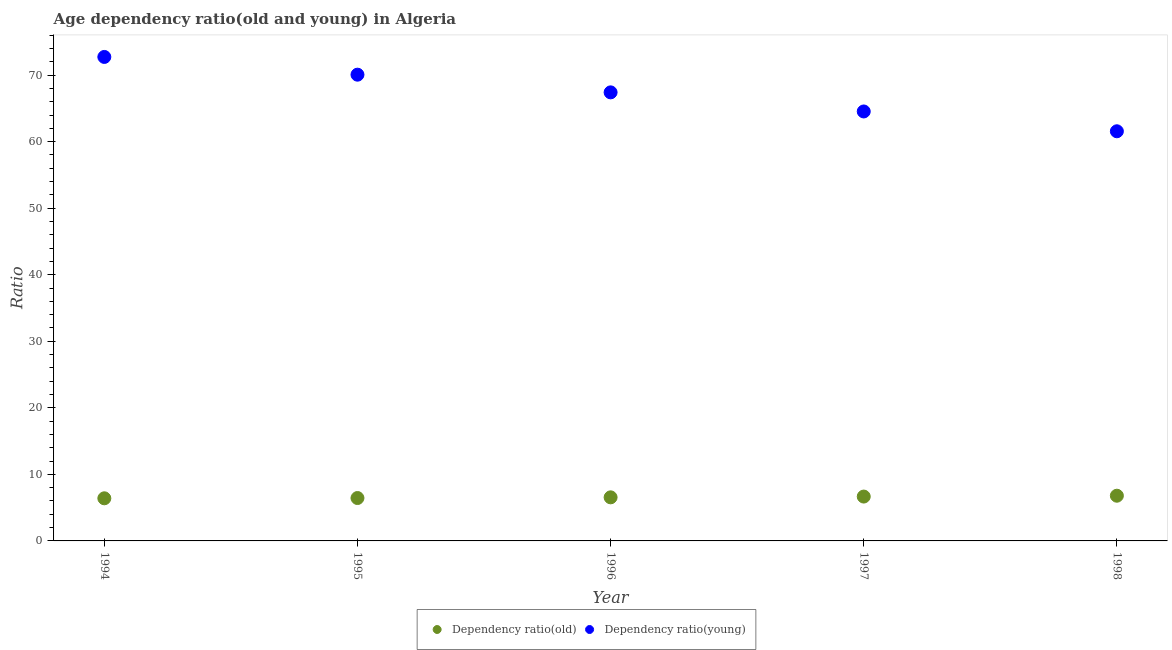How many different coloured dotlines are there?
Ensure brevity in your answer.  2. Is the number of dotlines equal to the number of legend labels?
Your answer should be very brief. Yes. What is the age dependency ratio(old) in 1994?
Make the answer very short. 6.41. Across all years, what is the maximum age dependency ratio(young)?
Offer a very short reply. 72.74. Across all years, what is the minimum age dependency ratio(young)?
Keep it short and to the point. 61.57. In which year was the age dependency ratio(young) maximum?
Your answer should be very brief. 1994. In which year was the age dependency ratio(young) minimum?
Offer a terse response. 1998. What is the total age dependency ratio(old) in the graph?
Keep it short and to the point. 32.86. What is the difference between the age dependency ratio(old) in 1996 and that in 1998?
Your response must be concise. -0.24. What is the difference between the age dependency ratio(young) in 1994 and the age dependency ratio(old) in 1998?
Ensure brevity in your answer.  65.94. What is the average age dependency ratio(young) per year?
Make the answer very short. 67.27. In the year 1998, what is the difference between the age dependency ratio(old) and age dependency ratio(young)?
Your answer should be compact. -54.77. In how many years, is the age dependency ratio(old) greater than 2?
Ensure brevity in your answer.  5. What is the ratio of the age dependency ratio(old) in 1994 to that in 1996?
Offer a very short reply. 0.98. Is the difference between the age dependency ratio(old) in 1994 and 1996 greater than the difference between the age dependency ratio(young) in 1994 and 1996?
Your response must be concise. No. What is the difference between the highest and the second highest age dependency ratio(young)?
Offer a terse response. 2.67. What is the difference between the highest and the lowest age dependency ratio(old)?
Offer a terse response. 0.39. Does the age dependency ratio(old) monotonically increase over the years?
Your answer should be very brief. Yes. What is the difference between two consecutive major ticks on the Y-axis?
Keep it short and to the point. 10. Are the values on the major ticks of Y-axis written in scientific E-notation?
Offer a very short reply. No. Where does the legend appear in the graph?
Give a very brief answer. Bottom center. How many legend labels are there?
Offer a terse response. 2. How are the legend labels stacked?
Offer a very short reply. Horizontal. What is the title of the graph?
Your answer should be compact. Age dependency ratio(old and young) in Algeria. Does "Underweight" appear as one of the legend labels in the graph?
Your answer should be very brief. No. What is the label or title of the X-axis?
Provide a short and direct response. Year. What is the label or title of the Y-axis?
Ensure brevity in your answer.  Ratio. What is the Ratio in Dependency ratio(old) in 1994?
Make the answer very short. 6.41. What is the Ratio in Dependency ratio(young) in 1994?
Offer a terse response. 72.74. What is the Ratio in Dependency ratio(old) in 1995?
Provide a short and direct response. 6.45. What is the Ratio of Dependency ratio(young) in 1995?
Give a very brief answer. 70.07. What is the Ratio in Dependency ratio(old) in 1996?
Your answer should be very brief. 6.55. What is the Ratio in Dependency ratio(young) in 1996?
Ensure brevity in your answer.  67.41. What is the Ratio of Dependency ratio(old) in 1997?
Offer a very short reply. 6.67. What is the Ratio of Dependency ratio(young) in 1997?
Your answer should be compact. 64.54. What is the Ratio of Dependency ratio(old) in 1998?
Your answer should be very brief. 6.79. What is the Ratio in Dependency ratio(young) in 1998?
Give a very brief answer. 61.57. Across all years, what is the maximum Ratio in Dependency ratio(old)?
Keep it short and to the point. 6.79. Across all years, what is the maximum Ratio of Dependency ratio(young)?
Keep it short and to the point. 72.74. Across all years, what is the minimum Ratio in Dependency ratio(old)?
Provide a succinct answer. 6.41. Across all years, what is the minimum Ratio in Dependency ratio(young)?
Provide a short and direct response. 61.57. What is the total Ratio of Dependency ratio(old) in the graph?
Make the answer very short. 32.86. What is the total Ratio of Dependency ratio(young) in the graph?
Ensure brevity in your answer.  336.33. What is the difference between the Ratio in Dependency ratio(old) in 1994 and that in 1995?
Provide a succinct answer. -0.04. What is the difference between the Ratio in Dependency ratio(young) in 1994 and that in 1995?
Your answer should be very brief. 2.67. What is the difference between the Ratio in Dependency ratio(old) in 1994 and that in 1996?
Provide a succinct answer. -0.14. What is the difference between the Ratio of Dependency ratio(young) in 1994 and that in 1996?
Provide a succinct answer. 5.32. What is the difference between the Ratio in Dependency ratio(old) in 1994 and that in 1997?
Give a very brief answer. -0.26. What is the difference between the Ratio of Dependency ratio(young) in 1994 and that in 1997?
Provide a succinct answer. 8.19. What is the difference between the Ratio of Dependency ratio(old) in 1994 and that in 1998?
Provide a succinct answer. -0.39. What is the difference between the Ratio in Dependency ratio(young) in 1994 and that in 1998?
Your answer should be very brief. 11.17. What is the difference between the Ratio in Dependency ratio(old) in 1995 and that in 1996?
Provide a short and direct response. -0.1. What is the difference between the Ratio of Dependency ratio(young) in 1995 and that in 1996?
Ensure brevity in your answer.  2.66. What is the difference between the Ratio of Dependency ratio(old) in 1995 and that in 1997?
Your answer should be compact. -0.22. What is the difference between the Ratio of Dependency ratio(young) in 1995 and that in 1997?
Offer a very short reply. 5.53. What is the difference between the Ratio of Dependency ratio(old) in 1995 and that in 1998?
Your answer should be compact. -0.35. What is the difference between the Ratio in Dependency ratio(young) in 1995 and that in 1998?
Provide a succinct answer. 8.51. What is the difference between the Ratio in Dependency ratio(old) in 1996 and that in 1997?
Give a very brief answer. -0.12. What is the difference between the Ratio in Dependency ratio(young) in 1996 and that in 1997?
Your response must be concise. 2.87. What is the difference between the Ratio of Dependency ratio(old) in 1996 and that in 1998?
Your response must be concise. -0.24. What is the difference between the Ratio in Dependency ratio(young) in 1996 and that in 1998?
Provide a succinct answer. 5.85. What is the difference between the Ratio of Dependency ratio(old) in 1997 and that in 1998?
Make the answer very short. -0.13. What is the difference between the Ratio in Dependency ratio(young) in 1997 and that in 1998?
Provide a short and direct response. 2.98. What is the difference between the Ratio of Dependency ratio(old) in 1994 and the Ratio of Dependency ratio(young) in 1995?
Ensure brevity in your answer.  -63.67. What is the difference between the Ratio of Dependency ratio(old) in 1994 and the Ratio of Dependency ratio(young) in 1996?
Make the answer very short. -61.01. What is the difference between the Ratio of Dependency ratio(old) in 1994 and the Ratio of Dependency ratio(young) in 1997?
Provide a succinct answer. -58.14. What is the difference between the Ratio of Dependency ratio(old) in 1994 and the Ratio of Dependency ratio(young) in 1998?
Your answer should be compact. -55.16. What is the difference between the Ratio of Dependency ratio(old) in 1995 and the Ratio of Dependency ratio(young) in 1996?
Make the answer very short. -60.97. What is the difference between the Ratio in Dependency ratio(old) in 1995 and the Ratio in Dependency ratio(young) in 1997?
Your answer should be very brief. -58.1. What is the difference between the Ratio of Dependency ratio(old) in 1995 and the Ratio of Dependency ratio(young) in 1998?
Provide a succinct answer. -55.12. What is the difference between the Ratio in Dependency ratio(old) in 1996 and the Ratio in Dependency ratio(young) in 1997?
Your answer should be compact. -57.99. What is the difference between the Ratio in Dependency ratio(old) in 1996 and the Ratio in Dependency ratio(young) in 1998?
Make the answer very short. -55.02. What is the difference between the Ratio of Dependency ratio(old) in 1997 and the Ratio of Dependency ratio(young) in 1998?
Offer a very short reply. -54.9. What is the average Ratio in Dependency ratio(old) per year?
Your response must be concise. 6.57. What is the average Ratio of Dependency ratio(young) per year?
Ensure brevity in your answer.  67.27. In the year 1994, what is the difference between the Ratio in Dependency ratio(old) and Ratio in Dependency ratio(young)?
Your response must be concise. -66.33. In the year 1995, what is the difference between the Ratio of Dependency ratio(old) and Ratio of Dependency ratio(young)?
Your response must be concise. -63.62. In the year 1996, what is the difference between the Ratio of Dependency ratio(old) and Ratio of Dependency ratio(young)?
Provide a short and direct response. -60.86. In the year 1997, what is the difference between the Ratio in Dependency ratio(old) and Ratio in Dependency ratio(young)?
Your answer should be very brief. -57.88. In the year 1998, what is the difference between the Ratio in Dependency ratio(old) and Ratio in Dependency ratio(young)?
Give a very brief answer. -54.77. What is the ratio of the Ratio of Dependency ratio(old) in 1994 to that in 1995?
Your answer should be compact. 0.99. What is the ratio of the Ratio of Dependency ratio(young) in 1994 to that in 1995?
Provide a short and direct response. 1.04. What is the ratio of the Ratio in Dependency ratio(old) in 1994 to that in 1996?
Your answer should be very brief. 0.98. What is the ratio of the Ratio of Dependency ratio(young) in 1994 to that in 1996?
Your response must be concise. 1.08. What is the ratio of the Ratio of Dependency ratio(old) in 1994 to that in 1997?
Ensure brevity in your answer.  0.96. What is the ratio of the Ratio of Dependency ratio(young) in 1994 to that in 1997?
Provide a succinct answer. 1.13. What is the ratio of the Ratio of Dependency ratio(old) in 1994 to that in 1998?
Offer a very short reply. 0.94. What is the ratio of the Ratio of Dependency ratio(young) in 1994 to that in 1998?
Offer a very short reply. 1.18. What is the ratio of the Ratio in Dependency ratio(old) in 1995 to that in 1996?
Your answer should be compact. 0.98. What is the ratio of the Ratio of Dependency ratio(young) in 1995 to that in 1996?
Your answer should be very brief. 1.04. What is the ratio of the Ratio in Dependency ratio(young) in 1995 to that in 1997?
Keep it short and to the point. 1.09. What is the ratio of the Ratio in Dependency ratio(old) in 1995 to that in 1998?
Provide a short and direct response. 0.95. What is the ratio of the Ratio of Dependency ratio(young) in 1995 to that in 1998?
Provide a short and direct response. 1.14. What is the ratio of the Ratio in Dependency ratio(old) in 1996 to that in 1997?
Make the answer very short. 0.98. What is the ratio of the Ratio of Dependency ratio(young) in 1996 to that in 1997?
Keep it short and to the point. 1.04. What is the ratio of the Ratio of Dependency ratio(old) in 1996 to that in 1998?
Your response must be concise. 0.96. What is the ratio of the Ratio of Dependency ratio(young) in 1996 to that in 1998?
Provide a short and direct response. 1.09. What is the ratio of the Ratio of Dependency ratio(old) in 1997 to that in 1998?
Your answer should be compact. 0.98. What is the ratio of the Ratio in Dependency ratio(young) in 1997 to that in 1998?
Offer a very short reply. 1.05. What is the difference between the highest and the second highest Ratio in Dependency ratio(old)?
Make the answer very short. 0.13. What is the difference between the highest and the second highest Ratio in Dependency ratio(young)?
Ensure brevity in your answer.  2.67. What is the difference between the highest and the lowest Ratio of Dependency ratio(old)?
Your answer should be compact. 0.39. What is the difference between the highest and the lowest Ratio in Dependency ratio(young)?
Make the answer very short. 11.17. 